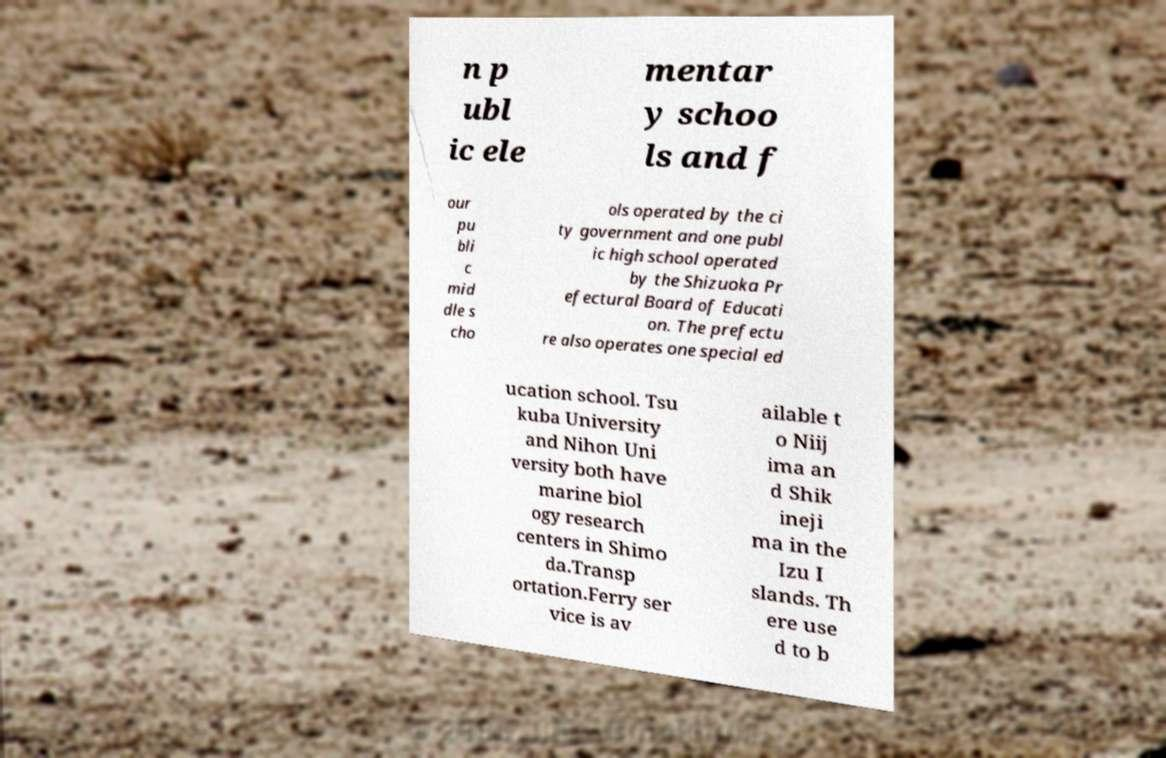Please identify and transcribe the text found in this image. n p ubl ic ele mentar y schoo ls and f our pu bli c mid dle s cho ols operated by the ci ty government and one publ ic high school operated by the Shizuoka Pr efectural Board of Educati on. The prefectu re also operates one special ed ucation school. Tsu kuba University and Nihon Uni versity both have marine biol ogy research centers in Shimo da.Transp ortation.Ferry ser vice is av ailable t o Niij ima an d Shik ineji ma in the Izu I slands. Th ere use d to b 